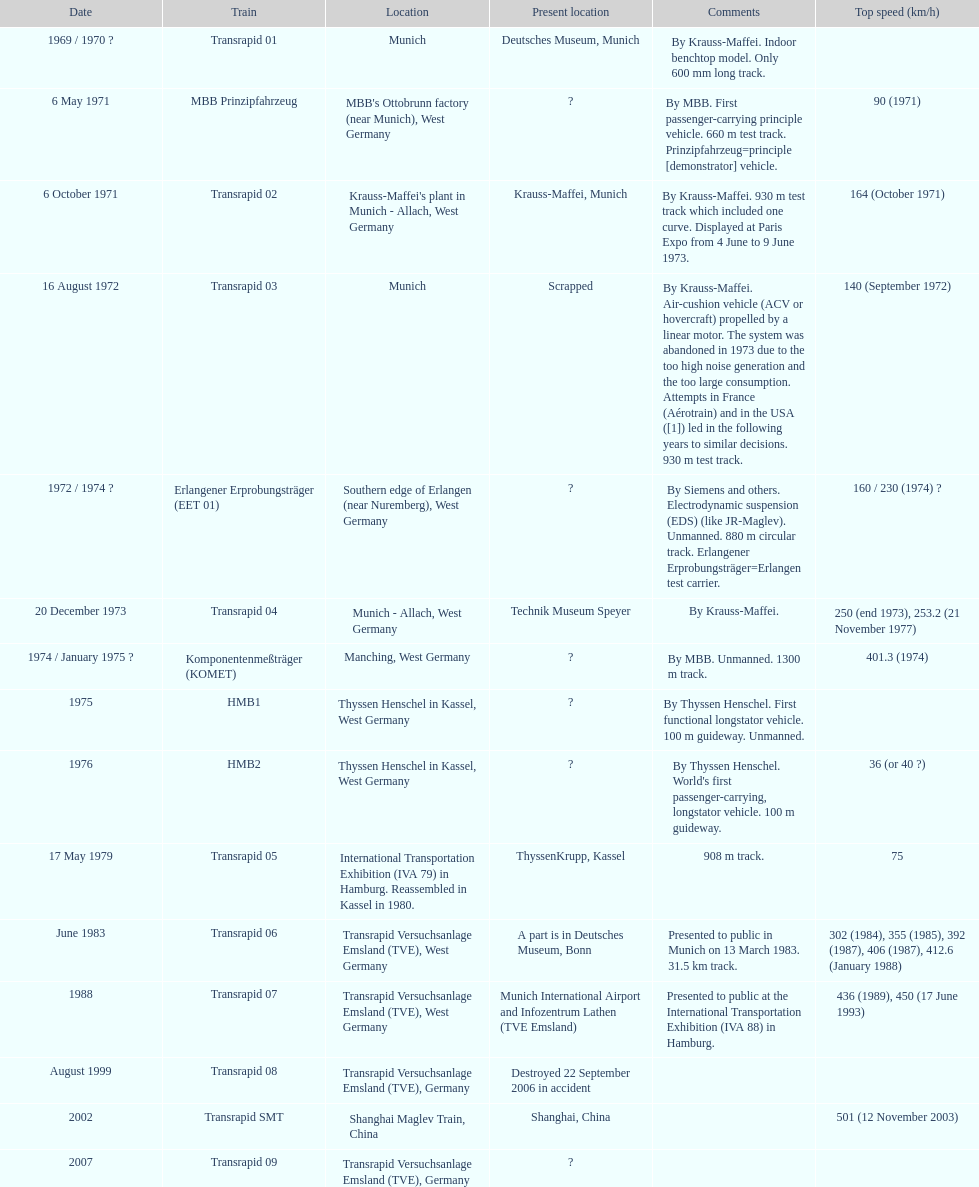What train was developed after the erlangener erprobungstrager? Transrapid 04. 